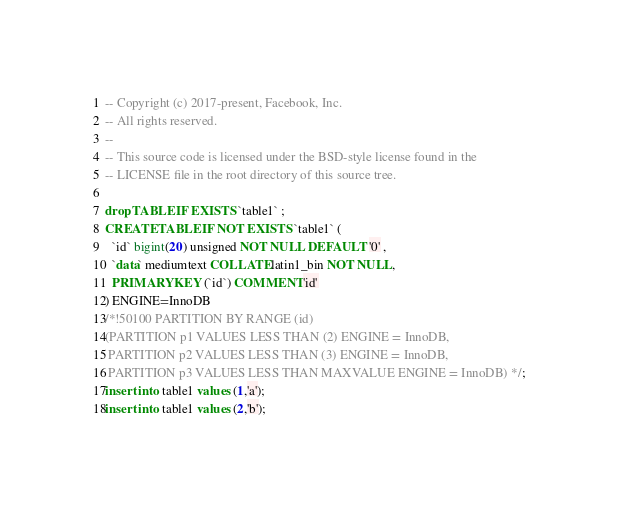<code> <loc_0><loc_0><loc_500><loc_500><_SQL_>-- Copyright (c) 2017-present, Facebook, Inc.
-- All rights reserved.
-- 
-- This source code is licensed under the BSD-style license found in the
-- LICENSE file in the root directory of this source tree.

drop TABLE IF EXISTS `table1` ;
CREATE TABLE IF NOT EXISTS `table1` (
  `id` bigint(20) unsigned NOT NULL DEFAULT '0' ,
  `data` mediumtext COLLATE latin1_bin NOT NULL,
  PRIMARY KEY (`id`) COMMENT 'id'
) ENGINE=InnoDB
/*!50100 PARTITION BY RANGE (id)
(PARTITION p1 VALUES LESS THAN (2) ENGINE = InnoDB,
 PARTITION p2 VALUES LESS THAN (3) ENGINE = InnoDB,
 PARTITION p3 VALUES LESS THAN MAXVALUE ENGINE = InnoDB) */;
insert into table1 values (1,'a');
insert into table1 values (2,'b');
</code> 